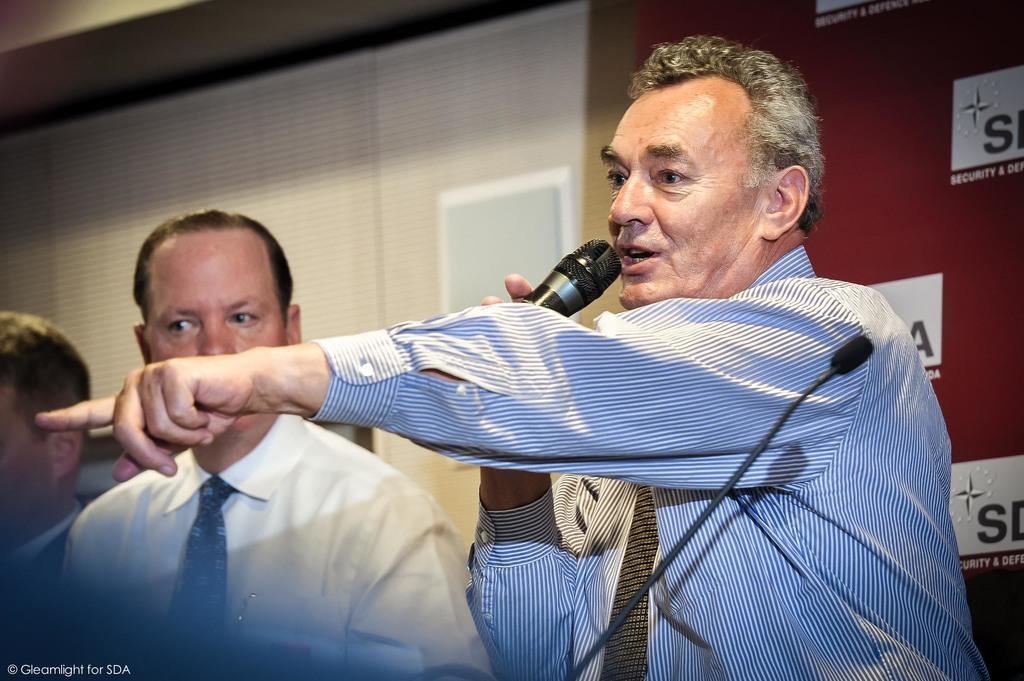Could you give a brief overview of what you see in this image? In this image there are three persons, one person is holding a mic in his hand, in the bottom left there is text, in the background there is wall to that there is curtain. 